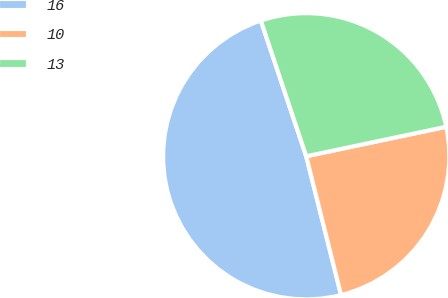<chart> <loc_0><loc_0><loc_500><loc_500><pie_chart><fcel>16<fcel>10<fcel>13<nl><fcel>48.78%<fcel>24.39%<fcel>26.83%<nl></chart> 